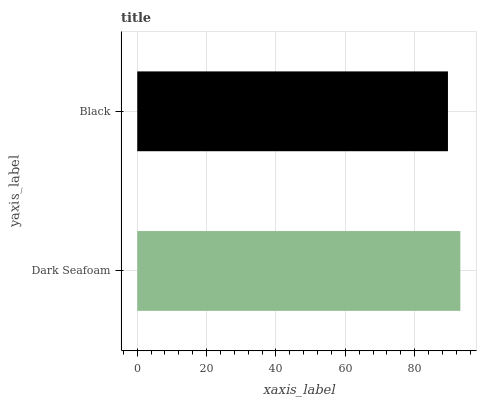Is Black the minimum?
Answer yes or no. Yes. Is Dark Seafoam the maximum?
Answer yes or no. Yes. Is Black the maximum?
Answer yes or no. No. Is Dark Seafoam greater than Black?
Answer yes or no. Yes. Is Black less than Dark Seafoam?
Answer yes or no. Yes. Is Black greater than Dark Seafoam?
Answer yes or no. No. Is Dark Seafoam less than Black?
Answer yes or no. No. Is Dark Seafoam the high median?
Answer yes or no. Yes. Is Black the low median?
Answer yes or no. Yes. Is Black the high median?
Answer yes or no. No. Is Dark Seafoam the low median?
Answer yes or no. No. 